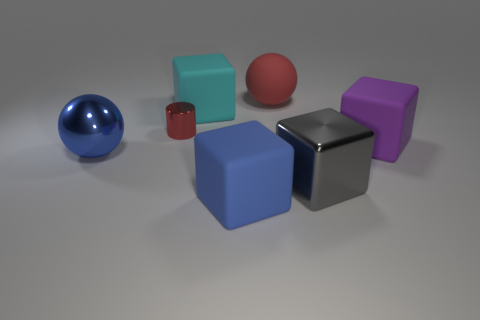Add 1 large red objects. How many objects exist? 8 Subtract all blocks. How many objects are left? 3 Add 2 tiny gray cylinders. How many tiny gray cylinders exist? 2 Subtract 0 gray cylinders. How many objects are left? 7 Subtract all small brown matte cylinders. Subtract all blue balls. How many objects are left? 6 Add 2 gray metallic blocks. How many gray metallic blocks are left? 3 